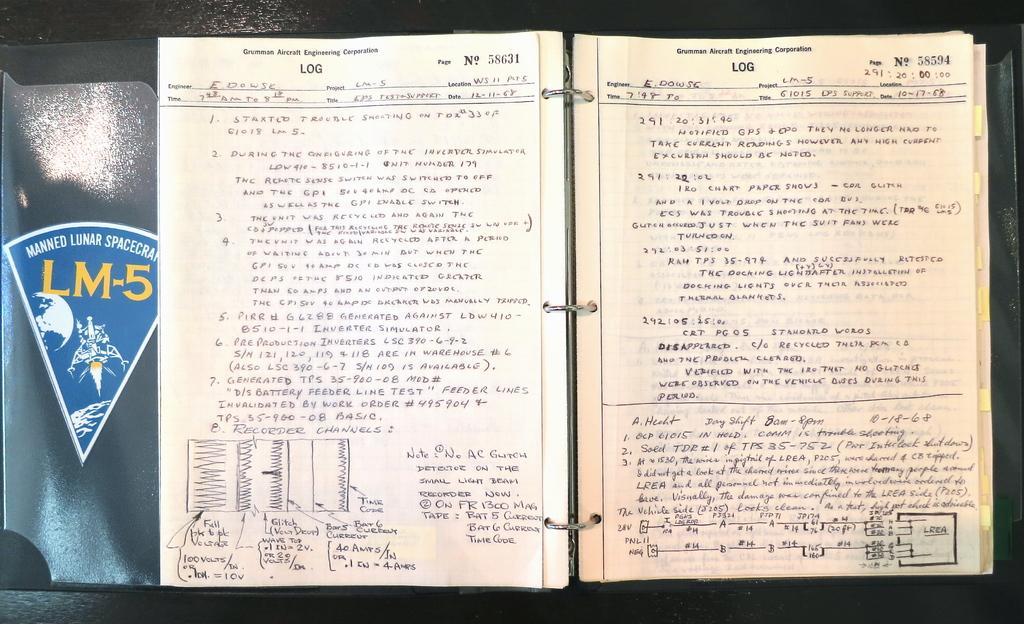<image>
Give a short and clear explanation of the subsequent image. A notebook is open and is filled with handwritten notes from 1968 for the Grumman Aircraft Engineering Corporation Log. 